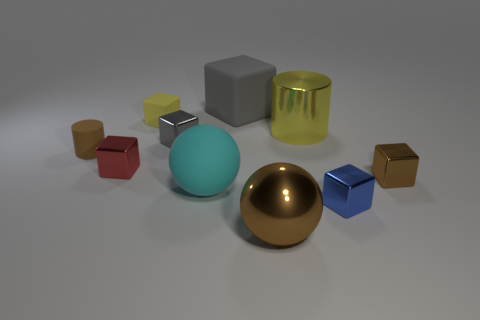What number of other objects are the same color as the big matte block?
Ensure brevity in your answer.  1. How many objects are either matte things to the left of the yellow matte object or tiny brown things?
Make the answer very short. 2. There is a small red thing that is the same material as the small brown block; what shape is it?
Offer a very short reply. Cube. Are there any other things that are the same shape as the small brown shiny thing?
Provide a succinct answer. Yes. What is the color of the metallic block that is both to the right of the yellow block and to the left of the tiny blue block?
Keep it short and to the point. Gray. How many cylinders are either large brown metal objects or brown metal objects?
Keep it short and to the point. 0. How many rubber blocks have the same size as the rubber ball?
Your response must be concise. 1. There is a metallic object right of the small blue block; what number of large cyan matte things are in front of it?
Ensure brevity in your answer.  1. How big is the metal object that is behind the brown cylinder and on the right side of the big cyan ball?
Keep it short and to the point. Large. Is the number of large blue matte cylinders greater than the number of blue shiny blocks?
Keep it short and to the point. No. 